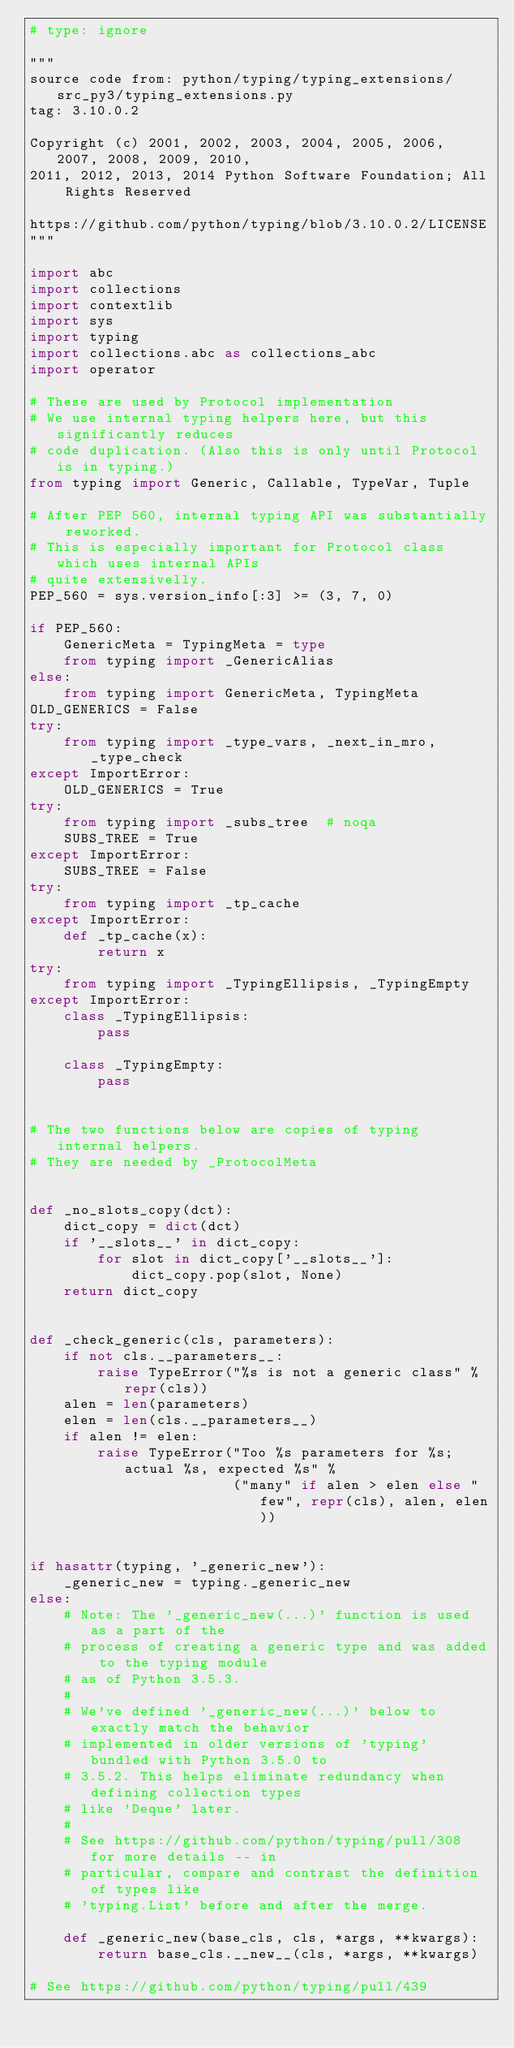<code> <loc_0><loc_0><loc_500><loc_500><_Python_># type: ignore

"""
source code from: python/typing/typing_extensions/src_py3/typing_extensions.py
tag: 3.10.0.2

Copyright (c) 2001, 2002, 2003, 2004, 2005, 2006, 2007, 2008, 2009, 2010,
2011, 2012, 2013, 2014 Python Software Foundation; All Rights Reserved

https://github.com/python/typing/blob/3.10.0.2/LICENSE
"""

import abc
import collections
import contextlib
import sys
import typing
import collections.abc as collections_abc
import operator

# These are used by Protocol implementation
# We use internal typing helpers here, but this significantly reduces
# code duplication. (Also this is only until Protocol is in typing.)
from typing import Generic, Callable, TypeVar, Tuple

# After PEP 560, internal typing API was substantially reworked.
# This is especially important for Protocol class which uses internal APIs
# quite extensivelly.
PEP_560 = sys.version_info[:3] >= (3, 7, 0)

if PEP_560:
    GenericMeta = TypingMeta = type
    from typing import _GenericAlias
else:
    from typing import GenericMeta, TypingMeta
OLD_GENERICS = False
try:
    from typing import _type_vars, _next_in_mro, _type_check
except ImportError:
    OLD_GENERICS = True
try:
    from typing import _subs_tree  # noqa
    SUBS_TREE = True
except ImportError:
    SUBS_TREE = False
try:
    from typing import _tp_cache
except ImportError:
    def _tp_cache(x):
        return x
try:
    from typing import _TypingEllipsis, _TypingEmpty
except ImportError:
    class _TypingEllipsis:
        pass

    class _TypingEmpty:
        pass


# The two functions below are copies of typing internal helpers.
# They are needed by _ProtocolMeta


def _no_slots_copy(dct):
    dict_copy = dict(dct)
    if '__slots__' in dict_copy:
        for slot in dict_copy['__slots__']:
            dict_copy.pop(slot, None)
    return dict_copy


def _check_generic(cls, parameters):
    if not cls.__parameters__:
        raise TypeError("%s is not a generic class" % repr(cls))
    alen = len(parameters)
    elen = len(cls.__parameters__)
    if alen != elen:
        raise TypeError("Too %s parameters for %s; actual %s, expected %s" %
                        ("many" if alen > elen else "few", repr(cls), alen, elen))


if hasattr(typing, '_generic_new'):
    _generic_new = typing._generic_new
else:
    # Note: The '_generic_new(...)' function is used as a part of the
    # process of creating a generic type and was added to the typing module
    # as of Python 3.5.3.
    #
    # We've defined '_generic_new(...)' below to exactly match the behavior
    # implemented in older versions of 'typing' bundled with Python 3.5.0 to
    # 3.5.2. This helps eliminate redundancy when defining collection types
    # like 'Deque' later.
    #
    # See https://github.com/python/typing/pull/308 for more details -- in
    # particular, compare and contrast the definition of types like
    # 'typing.List' before and after the merge.

    def _generic_new(base_cls, cls, *args, **kwargs):
        return base_cls.__new__(cls, *args, **kwargs)

# See https://github.com/python/typing/pull/439</code> 